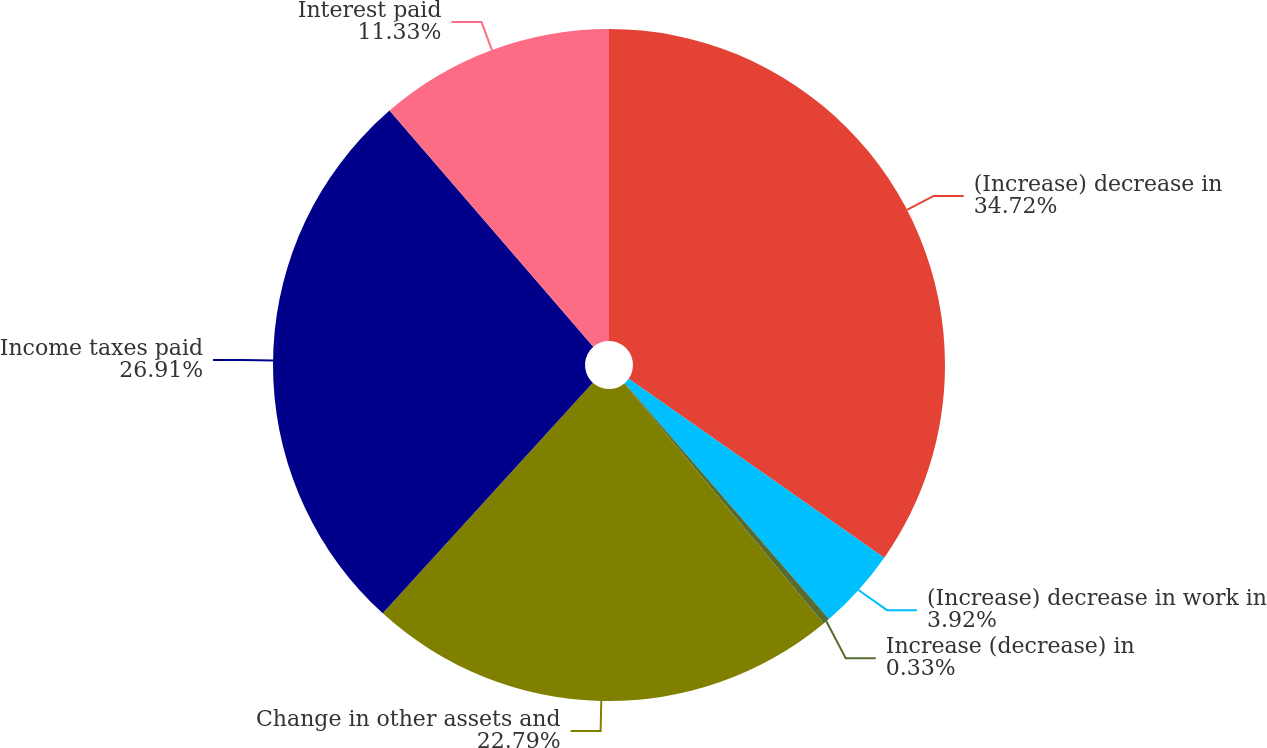Convert chart to OTSL. <chart><loc_0><loc_0><loc_500><loc_500><pie_chart><fcel>(Increase) decrease in<fcel>(Increase) decrease in work in<fcel>Increase (decrease) in<fcel>Change in other assets and<fcel>Income taxes paid<fcel>Interest paid<nl><fcel>34.72%<fcel>3.92%<fcel>0.33%<fcel>22.79%<fcel>26.91%<fcel>11.33%<nl></chart> 